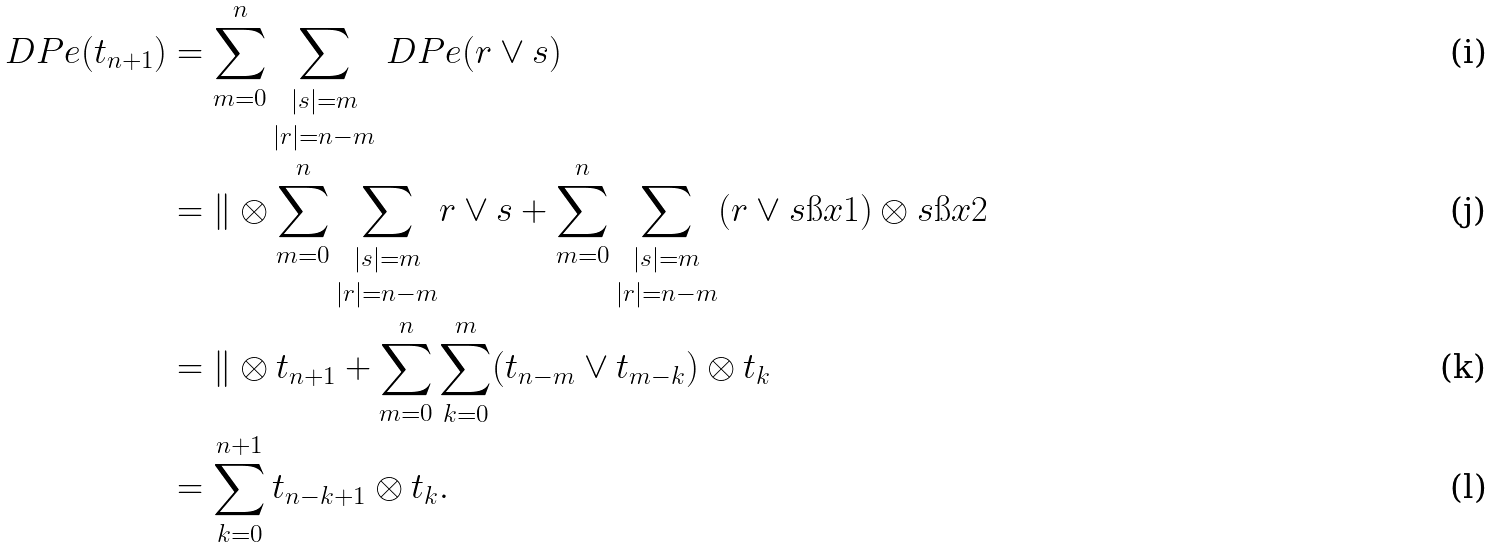<formula> <loc_0><loc_0><loc_500><loc_500>\ D P e ( t _ { n + 1 } ) & = \sum _ { m = 0 } ^ { n } \underset { | r | = n - m } { \sum _ { | s | = m } } \ D P e ( r \vee s ) \\ & = \| \otimes \sum _ { m = 0 } ^ { n } \underset { | r | = n - m } { \sum _ { | s | = m } } r \vee s + \sum _ { m = 0 } ^ { n } \underset { | r | = n - m } { \sum _ { | s | = m } } ( r \vee s \i x 1 ) \otimes s \i x 2 \\ & = \| \otimes t _ { n + 1 } + \sum _ { m = 0 } ^ { n } \sum _ { k = 0 } ^ { m } ( t _ { n - m } \vee t _ { m - k } ) \otimes t _ { k } \\ & = \sum _ { k = 0 } ^ { n + 1 } t _ { n - k + 1 } \otimes t _ { k } .</formula> 